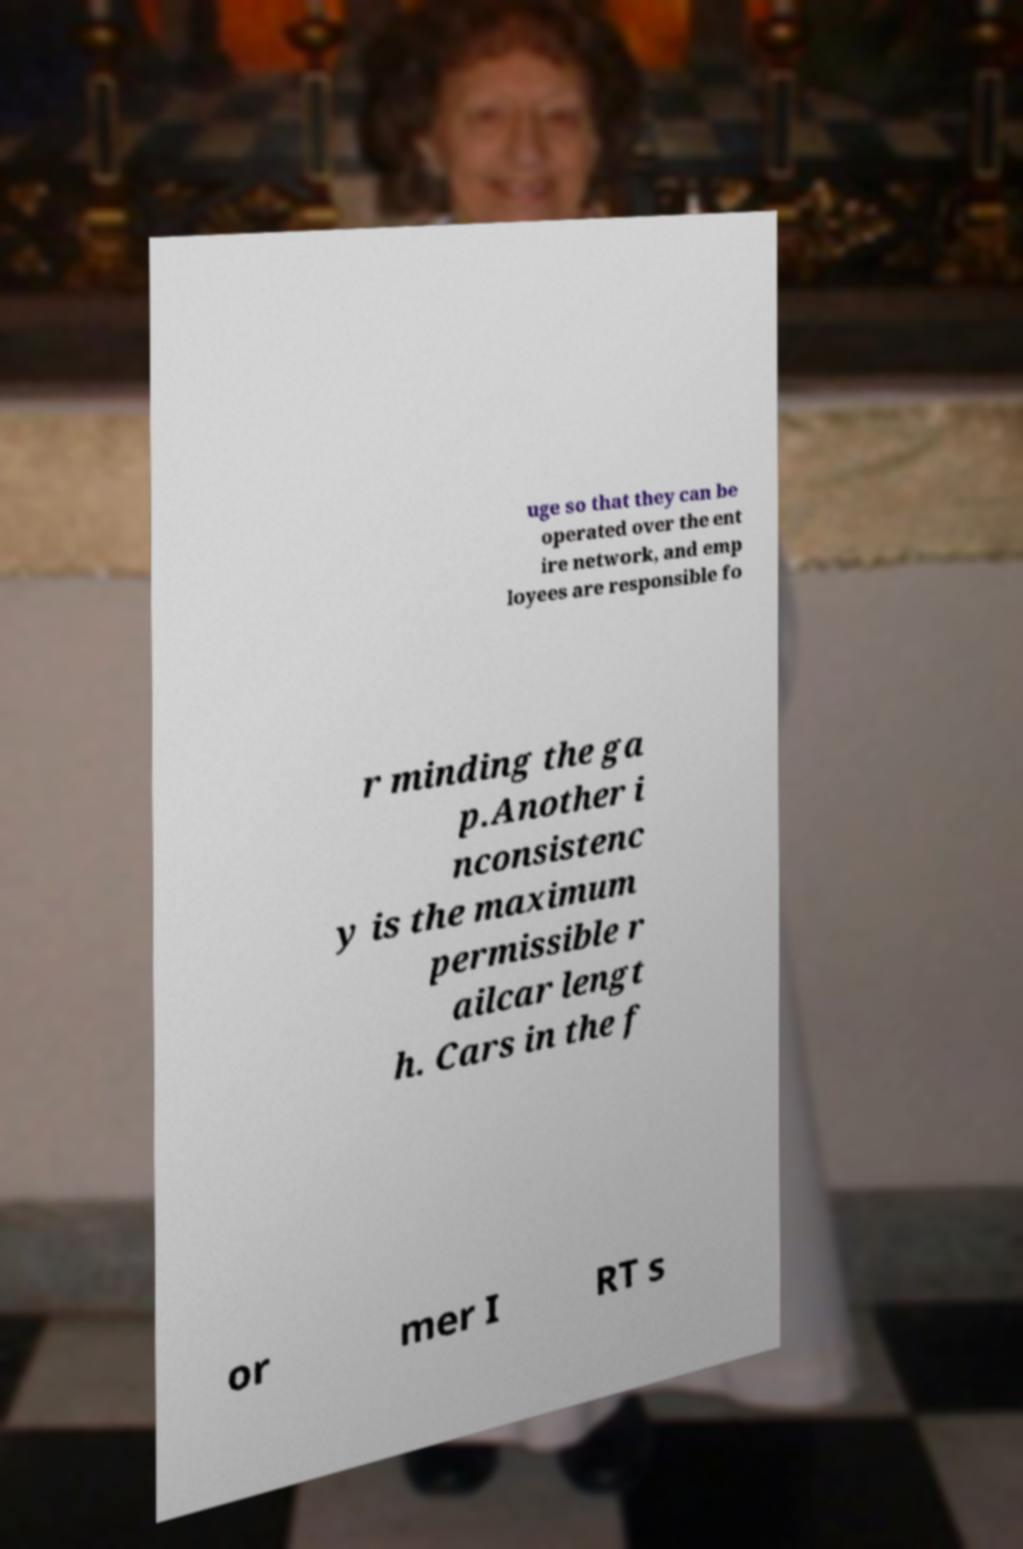Please read and relay the text visible in this image. What does it say? uge so that they can be operated over the ent ire network, and emp loyees are responsible fo r minding the ga p.Another i nconsistenc y is the maximum permissible r ailcar lengt h. Cars in the f or mer I RT s 